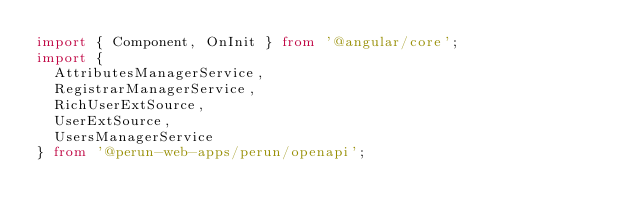<code> <loc_0><loc_0><loc_500><loc_500><_TypeScript_>import { Component, OnInit } from '@angular/core';
import {
  AttributesManagerService,
  RegistrarManagerService,
  RichUserExtSource,
  UserExtSource,
  UsersManagerService
} from '@perun-web-apps/perun/openapi';</code> 